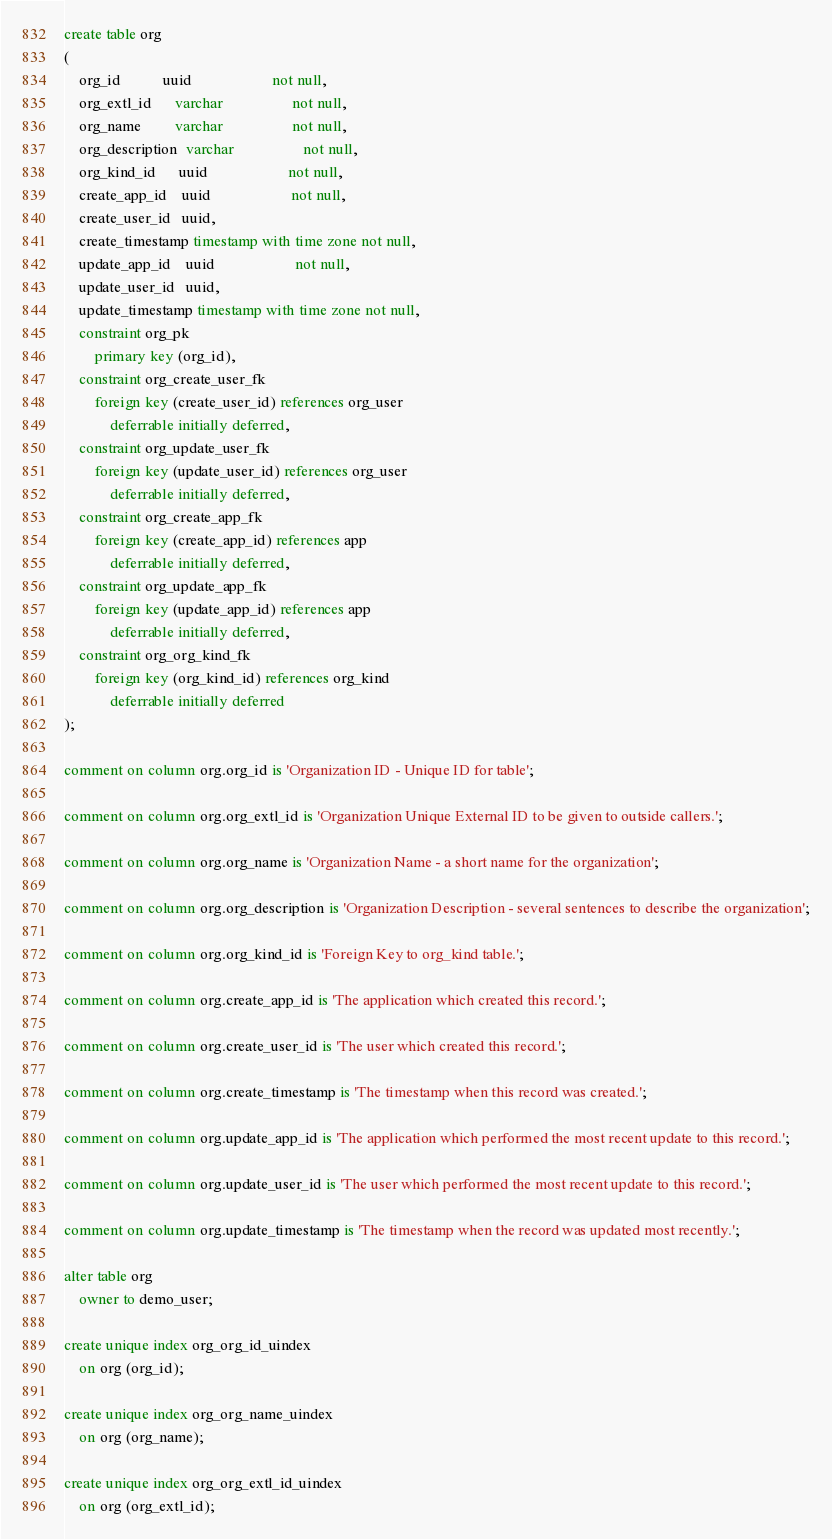<code> <loc_0><loc_0><loc_500><loc_500><_SQL_>create table org
(
    org_id           uuid                     not null,
    org_extl_id      varchar                  not null,
    org_name         varchar                  not null,
    org_description  varchar                  not null,
    org_kind_id      uuid                     not null,
    create_app_id    uuid                     not null,
    create_user_id   uuid,
    create_timestamp timestamp with time zone not null,
    update_app_id    uuid                     not null,
    update_user_id   uuid,
    update_timestamp timestamp with time zone not null,
    constraint org_pk
        primary key (org_id),
    constraint org_create_user_fk
        foreign key (create_user_id) references org_user
            deferrable initially deferred,
    constraint org_update_user_fk
        foreign key (update_user_id) references org_user
            deferrable initially deferred,
    constraint org_create_app_fk
        foreign key (create_app_id) references app
            deferrable initially deferred,
    constraint org_update_app_fk
        foreign key (update_app_id) references app
            deferrable initially deferred,
    constraint org_org_kind_fk
        foreign key (org_kind_id) references org_kind
            deferrable initially deferred
);

comment on column org.org_id is 'Organization ID - Unique ID for table';

comment on column org.org_extl_id is 'Organization Unique External ID to be given to outside callers.';

comment on column org.org_name is 'Organization Name - a short name for the organization';

comment on column org.org_description is 'Organization Description - several sentences to describe the organization';

comment on column org.org_kind_id is 'Foreign Key to org_kind table.';

comment on column org.create_app_id is 'The application which created this record.';

comment on column org.create_user_id is 'The user which created this record.';

comment on column org.create_timestamp is 'The timestamp when this record was created.';

comment on column org.update_app_id is 'The application which performed the most recent update to this record.';

comment on column org.update_user_id is 'The user which performed the most recent update to this record.';

comment on column org.update_timestamp is 'The timestamp when the record was updated most recently.';

alter table org
    owner to demo_user;

create unique index org_org_id_uindex
    on org (org_id);

create unique index org_org_name_uindex
    on org (org_name);

create unique index org_org_extl_id_uindex
    on org (org_extl_id);

</code> 